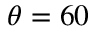<formula> <loc_0><loc_0><loc_500><loc_500>\theta = 6 0</formula> 